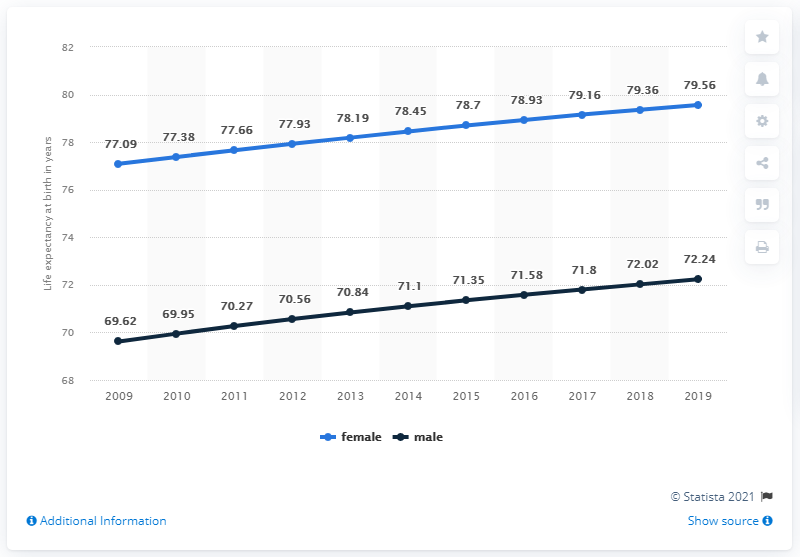List a handful of essential elements in this visual. According to estimates, males can expect to live approximately 71% of their life expectancy at the age of 4. The life expectancy for males in 2015 was 71.35 years, according to data. 